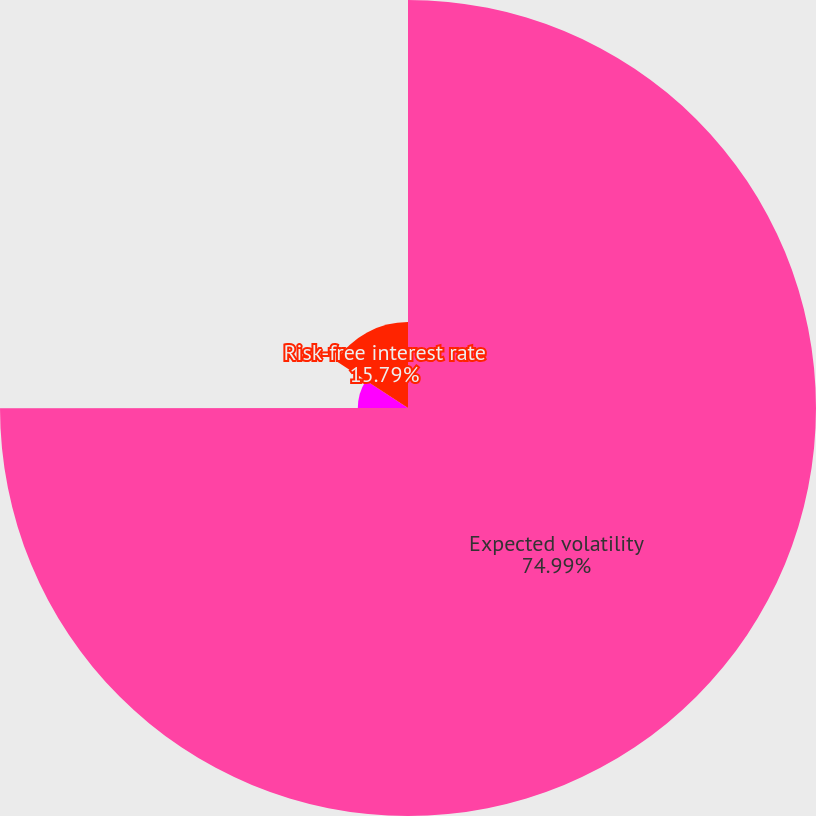Convert chart. <chart><loc_0><loc_0><loc_500><loc_500><pie_chart><fcel>Expected volatility<fcel>Expecteddividend yield<fcel>Risk-free interest rate<nl><fcel>74.99%<fcel>9.22%<fcel>15.79%<nl></chart> 